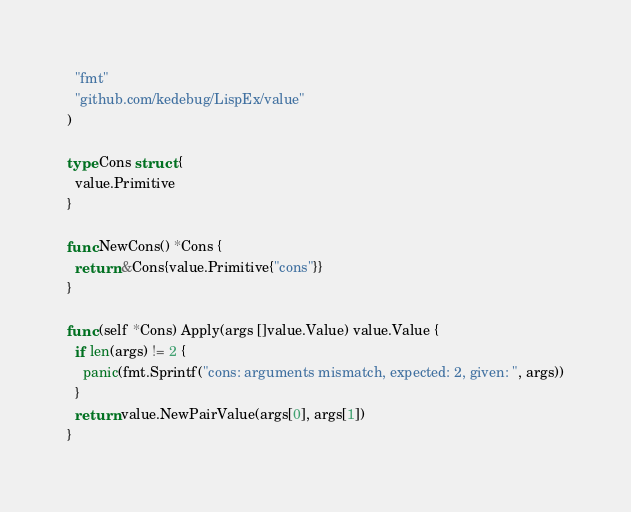<code> <loc_0><loc_0><loc_500><loc_500><_Go_>  "fmt"
  "github.com/kedebug/LispEx/value"
)

type Cons struct {
  value.Primitive
}

func NewCons() *Cons {
  return &Cons{value.Primitive{"cons"}}
}

func (self *Cons) Apply(args []value.Value) value.Value {
  if len(args) != 2 {
    panic(fmt.Sprintf("cons: arguments mismatch, expected: 2, given: ", args))
  }
  return value.NewPairValue(args[0], args[1])
}
</code> 